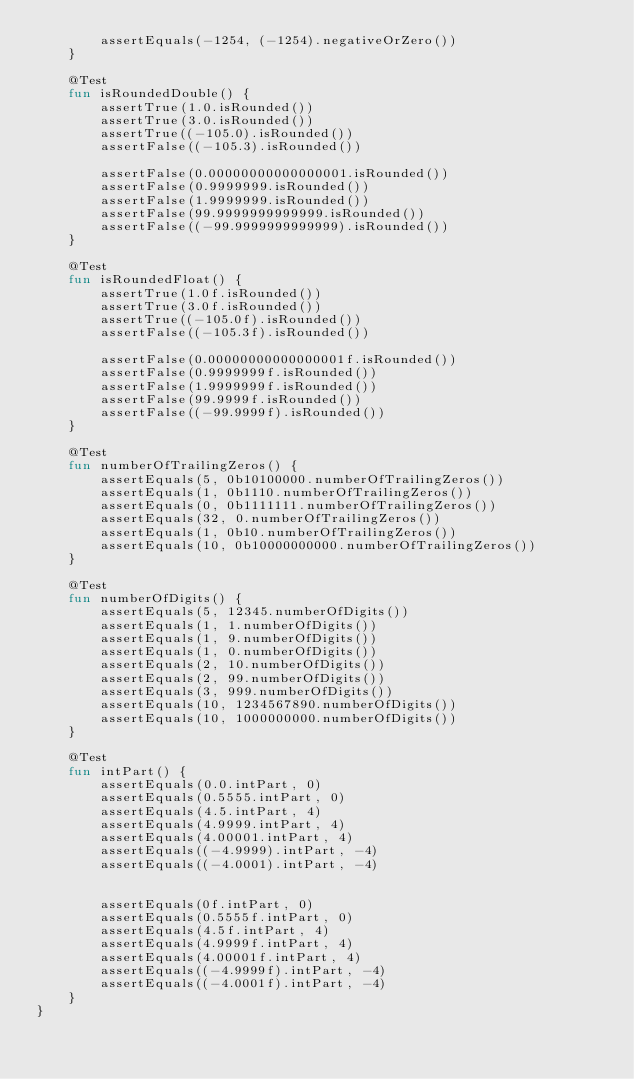Convert code to text. <code><loc_0><loc_0><loc_500><loc_500><_Kotlin_>        assertEquals(-1254, (-1254).negativeOrZero())
    }

    @Test
    fun isRoundedDouble() {
        assertTrue(1.0.isRounded())
        assertTrue(3.0.isRounded())
        assertTrue((-105.0).isRounded())
        assertFalse((-105.3).isRounded())

        assertFalse(0.00000000000000001.isRounded())
        assertFalse(0.9999999.isRounded())
        assertFalse(1.9999999.isRounded())
        assertFalse(99.9999999999999.isRounded())
        assertFalse((-99.9999999999999).isRounded())
    }

    @Test
    fun isRoundedFloat() {
        assertTrue(1.0f.isRounded())
        assertTrue(3.0f.isRounded())
        assertTrue((-105.0f).isRounded())
        assertFalse((-105.3f).isRounded())

        assertFalse(0.00000000000000001f.isRounded())
        assertFalse(0.9999999f.isRounded())
        assertFalse(1.9999999f.isRounded())
        assertFalse(99.9999f.isRounded())
        assertFalse((-99.9999f).isRounded())
    }

    @Test
    fun numberOfTrailingZeros() {
        assertEquals(5, 0b10100000.numberOfTrailingZeros())
        assertEquals(1, 0b1110.numberOfTrailingZeros())
        assertEquals(0, 0b1111111.numberOfTrailingZeros())
        assertEquals(32, 0.numberOfTrailingZeros())
        assertEquals(1, 0b10.numberOfTrailingZeros())
        assertEquals(10, 0b10000000000.numberOfTrailingZeros())
    }

    @Test
    fun numberOfDigits() {
        assertEquals(5, 12345.numberOfDigits())
        assertEquals(1, 1.numberOfDigits())
        assertEquals(1, 9.numberOfDigits())
        assertEquals(1, 0.numberOfDigits())
        assertEquals(2, 10.numberOfDigits())
        assertEquals(2, 99.numberOfDigits())
        assertEquals(3, 999.numberOfDigits())
        assertEquals(10, 1234567890.numberOfDigits())
        assertEquals(10, 1000000000.numberOfDigits())
    }

    @Test
    fun intPart() {
        assertEquals(0.0.intPart, 0)
        assertEquals(0.5555.intPart, 0)
        assertEquals(4.5.intPart, 4)
        assertEquals(4.9999.intPart, 4)
        assertEquals(4.00001.intPart, 4)
        assertEquals((-4.9999).intPart, -4)
        assertEquals((-4.0001).intPart, -4)


        assertEquals(0f.intPart, 0)
        assertEquals(0.5555f.intPart, 0)
        assertEquals(4.5f.intPart, 4)
        assertEquals(4.9999f.intPart, 4)
        assertEquals(4.00001f.intPart, 4)
        assertEquals((-4.9999f).intPart, -4)
        assertEquals((-4.0001f).intPart, -4)
    }
}</code> 